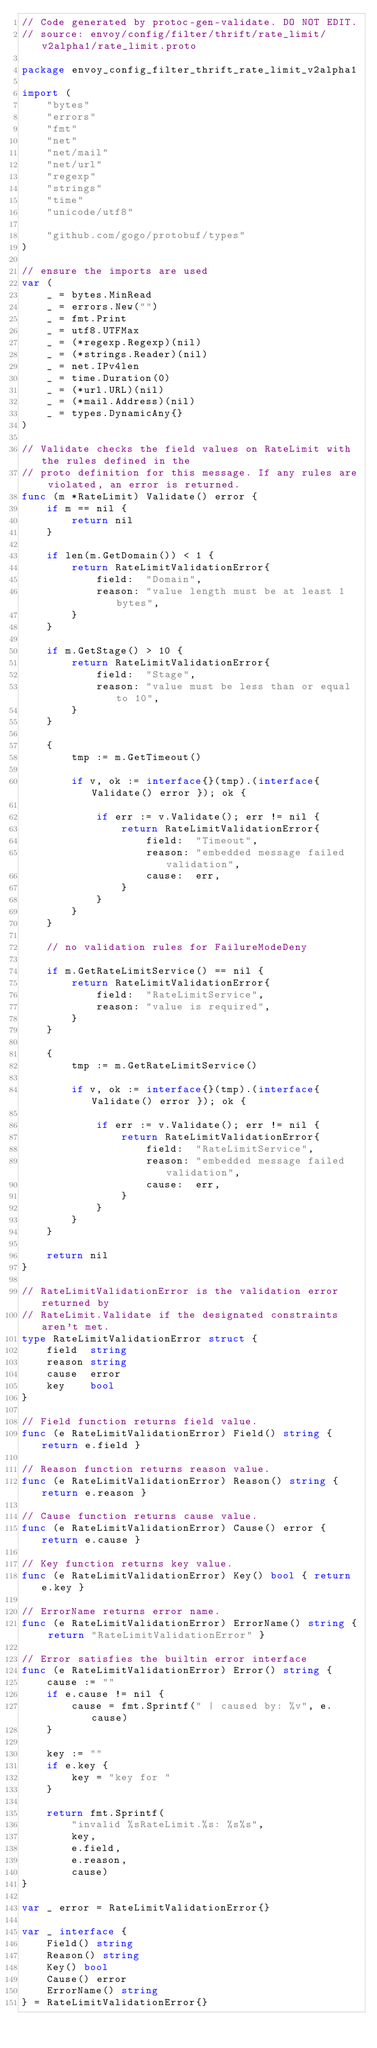Convert code to text. <code><loc_0><loc_0><loc_500><loc_500><_Go_>// Code generated by protoc-gen-validate. DO NOT EDIT.
// source: envoy/config/filter/thrift/rate_limit/v2alpha1/rate_limit.proto

package envoy_config_filter_thrift_rate_limit_v2alpha1

import (
	"bytes"
	"errors"
	"fmt"
	"net"
	"net/mail"
	"net/url"
	"regexp"
	"strings"
	"time"
	"unicode/utf8"

	"github.com/gogo/protobuf/types"
)

// ensure the imports are used
var (
	_ = bytes.MinRead
	_ = errors.New("")
	_ = fmt.Print
	_ = utf8.UTFMax
	_ = (*regexp.Regexp)(nil)
	_ = (*strings.Reader)(nil)
	_ = net.IPv4len
	_ = time.Duration(0)
	_ = (*url.URL)(nil)
	_ = (*mail.Address)(nil)
	_ = types.DynamicAny{}
)

// Validate checks the field values on RateLimit with the rules defined in the
// proto definition for this message. If any rules are violated, an error is returned.
func (m *RateLimit) Validate() error {
	if m == nil {
		return nil
	}

	if len(m.GetDomain()) < 1 {
		return RateLimitValidationError{
			field:  "Domain",
			reason: "value length must be at least 1 bytes",
		}
	}

	if m.GetStage() > 10 {
		return RateLimitValidationError{
			field:  "Stage",
			reason: "value must be less than or equal to 10",
		}
	}

	{
		tmp := m.GetTimeout()

		if v, ok := interface{}(tmp).(interface{ Validate() error }); ok {

			if err := v.Validate(); err != nil {
				return RateLimitValidationError{
					field:  "Timeout",
					reason: "embedded message failed validation",
					cause:  err,
				}
			}
		}
	}

	// no validation rules for FailureModeDeny

	if m.GetRateLimitService() == nil {
		return RateLimitValidationError{
			field:  "RateLimitService",
			reason: "value is required",
		}
	}

	{
		tmp := m.GetRateLimitService()

		if v, ok := interface{}(tmp).(interface{ Validate() error }); ok {

			if err := v.Validate(); err != nil {
				return RateLimitValidationError{
					field:  "RateLimitService",
					reason: "embedded message failed validation",
					cause:  err,
				}
			}
		}
	}

	return nil
}

// RateLimitValidationError is the validation error returned by
// RateLimit.Validate if the designated constraints aren't met.
type RateLimitValidationError struct {
	field  string
	reason string
	cause  error
	key    bool
}

// Field function returns field value.
func (e RateLimitValidationError) Field() string { return e.field }

// Reason function returns reason value.
func (e RateLimitValidationError) Reason() string { return e.reason }

// Cause function returns cause value.
func (e RateLimitValidationError) Cause() error { return e.cause }

// Key function returns key value.
func (e RateLimitValidationError) Key() bool { return e.key }

// ErrorName returns error name.
func (e RateLimitValidationError) ErrorName() string { return "RateLimitValidationError" }

// Error satisfies the builtin error interface
func (e RateLimitValidationError) Error() string {
	cause := ""
	if e.cause != nil {
		cause = fmt.Sprintf(" | caused by: %v", e.cause)
	}

	key := ""
	if e.key {
		key = "key for "
	}

	return fmt.Sprintf(
		"invalid %sRateLimit.%s: %s%s",
		key,
		e.field,
		e.reason,
		cause)
}

var _ error = RateLimitValidationError{}

var _ interface {
	Field() string
	Reason() string
	Key() bool
	Cause() error
	ErrorName() string
} = RateLimitValidationError{}
</code> 